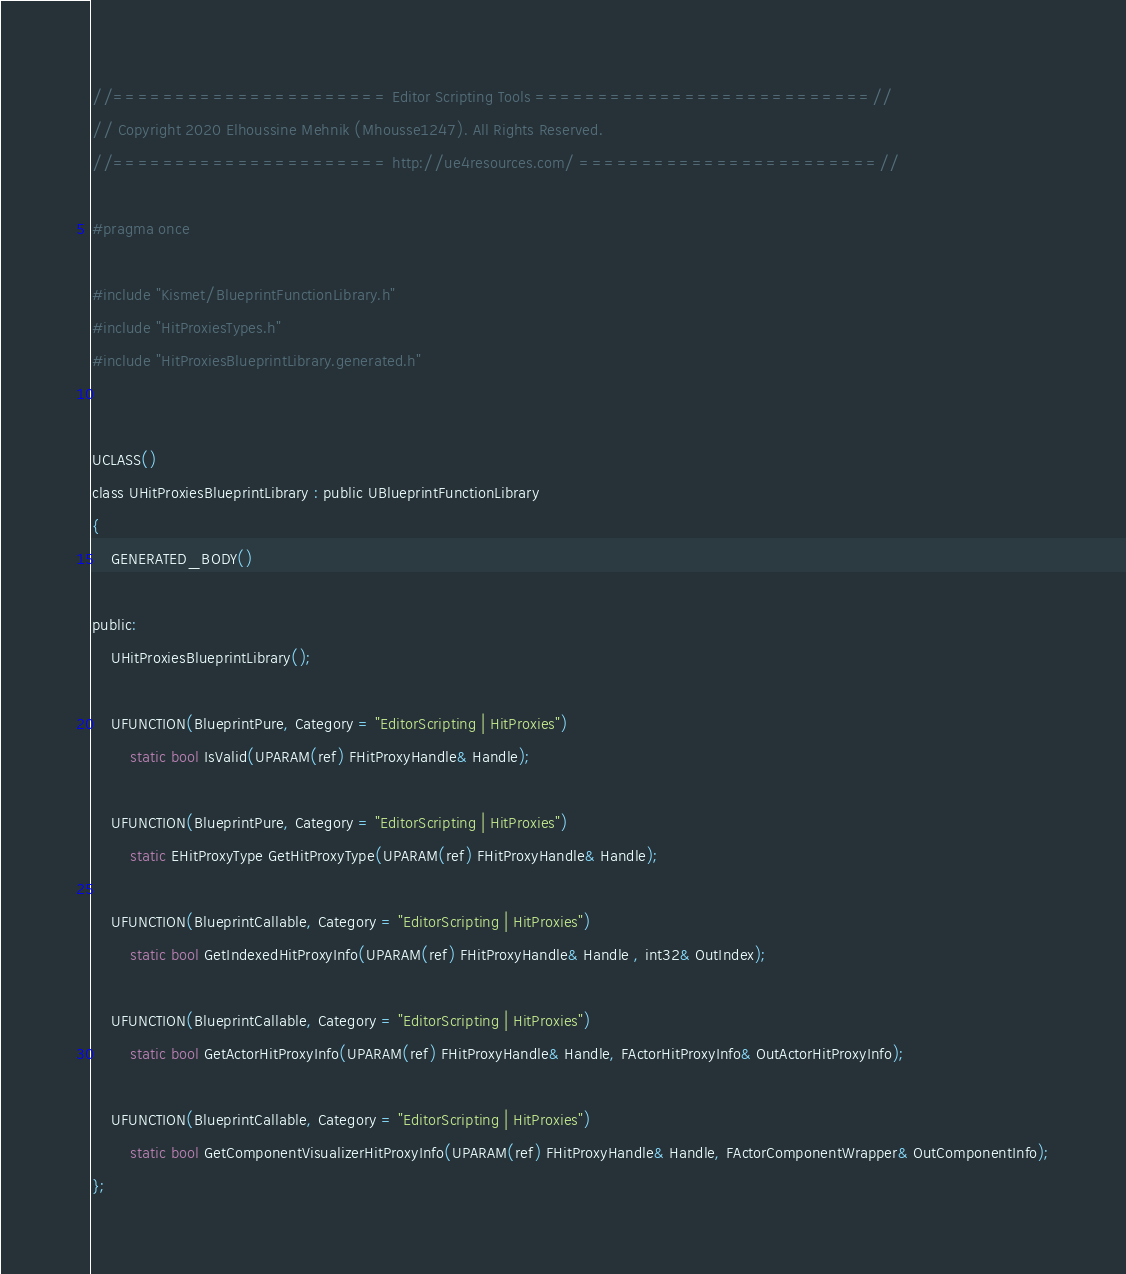Convert code to text. <code><loc_0><loc_0><loc_500><loc_500><_C_>//====================== Editor Scripting Tools ===========================//
// Copyright 2020 Elhoussine Mehnik (Mhousse1247). All Rights Reserved.
//====================== http://ue4resources.com/ ========================//

#pragma once

#include "Kismet/BlueprintFunctionLibrary.h"
#include "HitProxiesTypes.h"
#include "HitProxiesBlueprintLibrary.generated.h"


UCLASS()
class UHitProxiesBlueprintLibrary : public UBlueprintFunctionLibrary
{
	GENERATED_BODY()

public:
	UHitProxiesBlueprintLibrary();

	UFUNCTION(BlueprintPure, Category = "EditorScripting | HitProxies")
		static bool IsValid(UPARAM(ref) FHitProxyHandle& Handle);

	UFUNCTION(BlueprintPure, Category = "EditorScripting | HitProxies")
		static EHitProxyType GetHitProxyType(UPARAM(ref) FHitProxyHandle& Handle);

	UFUNCTION(BlueprintCallable, Category = "EditorScripting | HitProxies")
		static bool GetIndexedHitProxyInfo(UPARAM(ref) FHitProxyHandle& Handle , int32& OutIndex);

	UFUNCTION(BlueprintCallable, Category = "EditorScripting | HitProxies")
		static bool GetActorHitProxyInfo(UPARAM(ref) FHitProxyHandle& Handle, FActorHitProxyInfo& OutActorHitProxyInfo);

	UFUNCTION(BlueprintCallable, Category = "EditorScripting | HitProxies")
		static bool GetComponentVisualizerHitProxyInfo(UPARAM(ref) FHitProxyHandle& Handle, FActorComponentWrapper& OutComponentInfo);
};</code> 